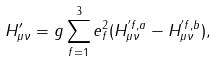<formula> <loc_0><loc_0><loc_500><loc_500>H ^ { \prime } _ { \mu \nu } = g \sum _ { f = 1 } ^ { 3 } e _ { f } ^ { 2 } ( H _ { \mu \nu } ^ { ^ { \prime } f , a } - H _ { \mu \nu } ^ { ^ { \prime } f , b } ) ,</formula> 